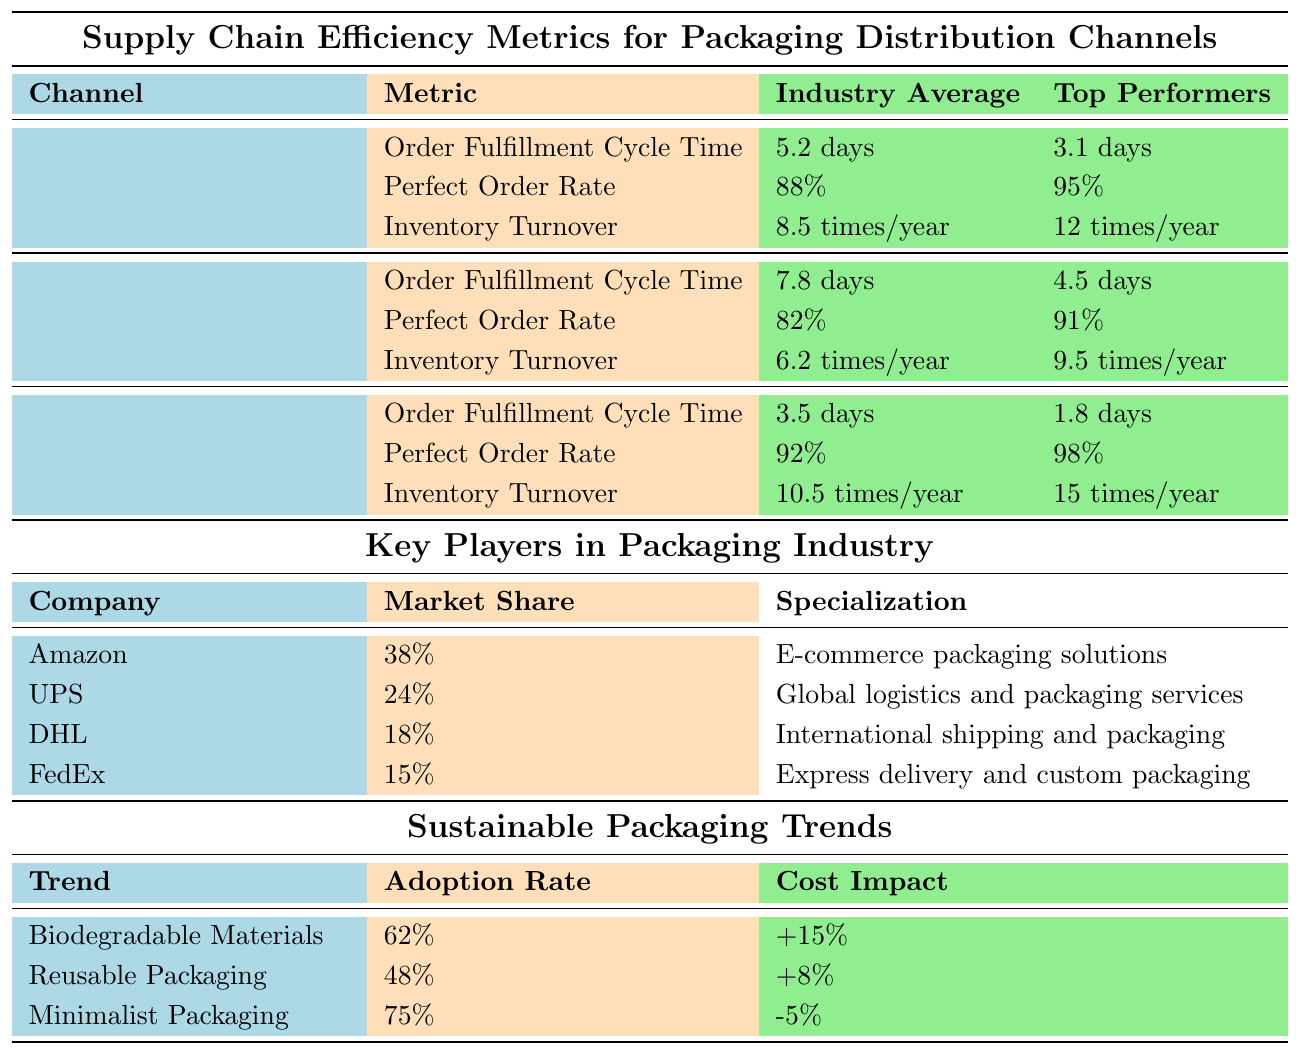What is the Order Fulfillment Cycle Time for E-commerce? The table shows that the Order Fulfillment Cycle Time for E-commerce is listed as 3.5 days.
Answer: 3.5 days Which channel has the highest Perfect Order Rate? By comparing the Perfect Order Rates for all channels, E-commerce has the highest rate at 92%.
Answer: E-commerce Calculate the difference in Inventory Turnover between Direct-to-Retailer and Wholesale Distribution. The Inventory Turnover for Direct-to-Retailer is 8.5 times/year, and for Wholesale Distribution, it is 6.2 times/year. Subtracting these gives: 8.5 - 6.2 = 2.3 times/year.
Answer: 2.3 times/year Is the Inventory Turnover for top performers in the E-commerce channel higher than that of the Wholesale Distribution channel? The Inventory Turnover for top performers in E-commerce is 15 times/year, while for Wholesale Distribution, it is 9.5 times/year. Since 15 > 9.5, the statement is true.
Answer: Yes What is the average Order Fulfillment Cycle Time across all distribution channels? The average can be calculated by adding the Order Fulfillment Cycle Times of all channels (5.2 + 7.8 + 3.5 = 16.5 days) and dividing by the number of channels (3), which results in: 16.5 / 3 = 5.5 days.
Answer: 5.5 days Which packaging trend has the highest adoption rate? Looking at the adoption rates for all trends, Minimalist Packaging has the highest adoption rate at 75%.
Answer: Minimalist Packaging How does the cost impact of Reusable Packaging compare to Biodegradable Materials? The cost impact for Reusable Packaging is +8%, while for Biodegradable Materials it is +15%. Comparing these shows that +15% > +8%, thus Biodegradable Materials has a higher cost impact.
Answer: Higher for Biodegradable Materials Are the top performers in Order Fulfillment Cycle Time more efficient in the E-commerce channel than in the Wholesale Distribution channel? For E-commerce, the top performer’s Order Fulfillment Cycle Time is 1.8 days, and for Wholesale Distribution, it is 4.5 days. Since 1.8 < 4.5, E-commerce shows more efficiency.
Answer: Yes What percentage of the market does Amazon control according to the table? The table indicates that Amazon has a market share of 38%.
Answer: 38% Which metric for Wholesale Distribution has the least value among all listed metrics? The values for Wholesale Distribution metrics are 7.8 days, 82%, and 6.2 times/year. Among these, the value of 6.2 times/year for Inventory Turnover is the least.
Answer: Inventory Turnover (6.2 times/year) 